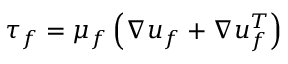<formula> <loc_0><loc_0><loc_500><loc_500>\tau _ { f } = \mu _ { f } \left ( \nabla u _ { f } + \nabla u _ { f } ^ { T } \right )</formula> 